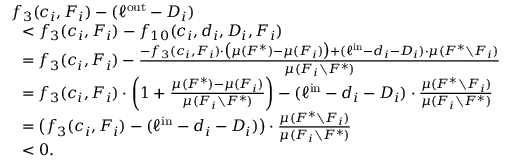Convert formula to latex. <formula><loc_0><loc_0><loc_500><loc_500>\begin{array} { r l } & { f _ { 3 } ( c _ { i } , F _ { i } ) - ( \ell ^ { o u t } - D _ { i } ) } & { < f _ { 3 } ( c _ { i } , F _ { i } ) - f _ { 1 0 } ( c _ { i } , d _ { i } , D _ { i } , F _ { i } ) } & { = f _ { 3 } ( c _ { i } , F _ { i } ) - \frac { - f _ { 3 } ( c _ { i } , F _ { i } ) \cdot \left ( \mu ( F ^ { * } ) - \mu ( F _ { i } ) \right ) + ( \ell ^ { i n } - d _ { i } - D _ { i } ) \cdot \mu ( F ^ { * } \ F _ { i } ) } { \mu ( F _ { i } \ F ^ { * } ) } } & { = f _ { 3 } ( c _ { i } , F _ { i } ) \cdot \left ( 1 + \frac { \mu ( F ^ { * } ) - \mu ( F _ { i } ) } { \mu ( F _ { i } \ F ^ { * } ) } \right ) - ( \ell ^ { i n } - d _ { i } - D _ { i } ) \cdot \frac { \mu ( F ^ { * } \ F _ { i } ) } { \mu ( F _ { i } \ F ^ { * } ) } } & { = \left ( f _ { 3 } ( c _ { i } , F _ { i } ) - ( \ell ^ { i n } - d _ { i } - D _ { i } ) \right ) \cdot \frac { \mu ( F ^ { * } \ F _ { i } ) } { \mu ( F _ { i } \ F ^ { * } ) } } & { < 0 . } \end{array}</formula> 